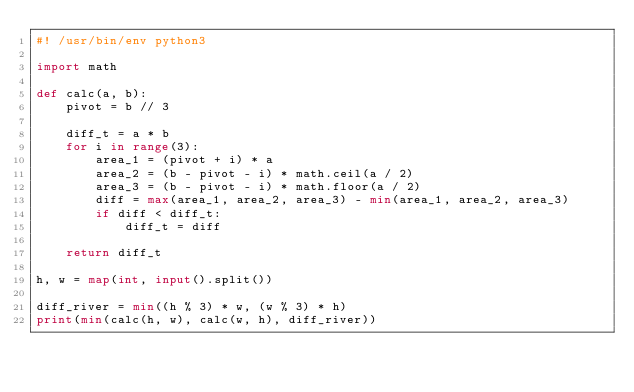<code> <loc_0><loc_0><loc_500><loc_500><_Python_>#! /usr/bin/env python3

import math

def calc(a, b):
    pivot = b // 3

    diff_t = a * b
    for i in range(3):
        area_1 = (pivot + i) * a
        area_2 = (b - pivot - i) * math.ceil(a / 2)
        area_3 = (b - pivot - i) * math.floor(a / 2)
        diff = max(area_1, area_2, area_3) - min(area_1, area_2, area_3)
        if diff < diff_t:
            diff_t = diff

    return diff_t

h, w = map(int, input().split())

diff_river = min((h % 3) * w, (w % 3) * h)
print(min(calc(h, w), calc(w, h), diff_river))
</code> 